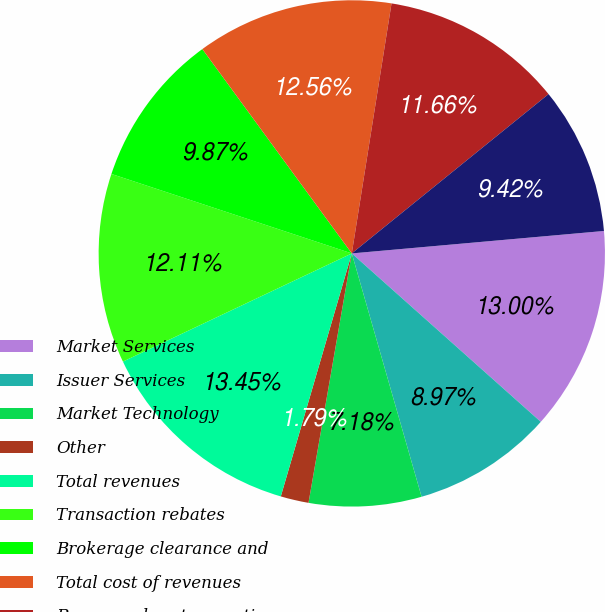Convert chart to OTSL. <chart><loc_0><loc_0><loc_500><loc_500><pie_chart><fcel>Market Services<fcel>Issuer Services<fcel>Market Technology<fcel>Other<fcel>Total revenues<fcel>Transaction rebates<fcel>Brokerage clearance and<fcel>Total cost of revenues<fcel>Revenues less transaction<fcel>Compensation and benefits<nl><fcel>13.0%<fcel>8.97%<fcel>7.18%<fcel>1.79%<fcel>13.45%<fcel>12.11%<fcel>9.87%<fcel>12.56%<fcel>11.66%<fcel>9.42%<nl></chart> 